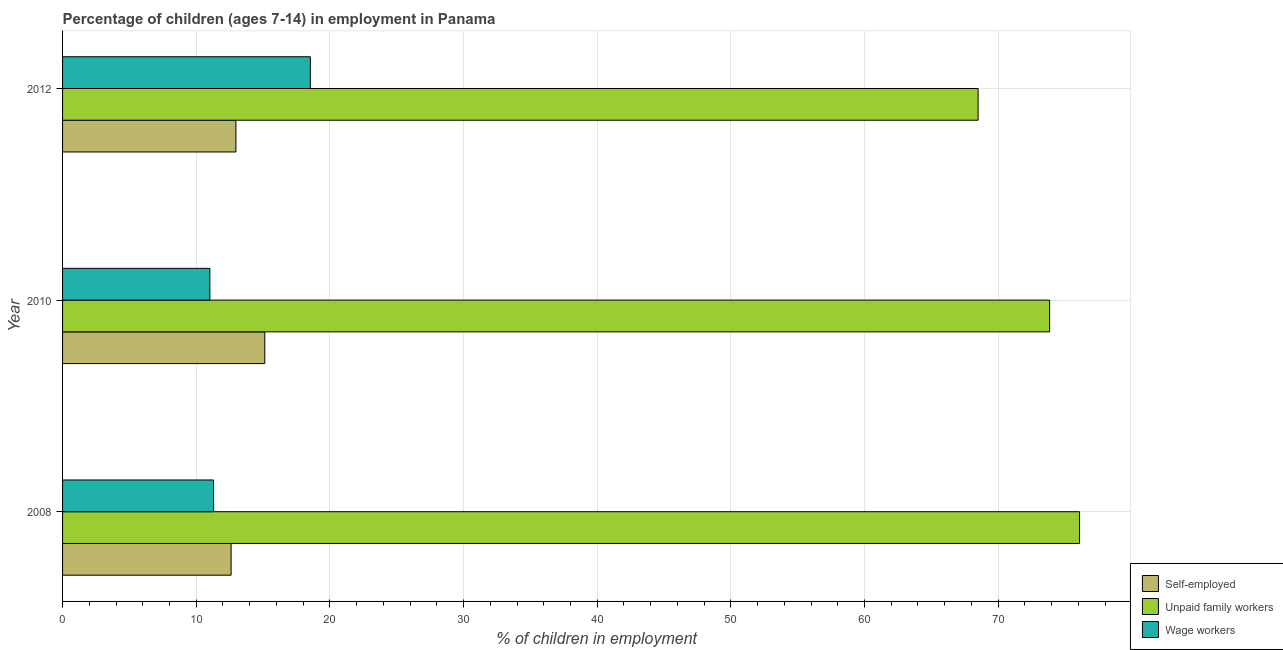Are the number of bars per tick equal to the number of legend labels?
Your response must be concise. Yes. How many bars are there on the 2nd tick from the top?
Your response must be concise. 3. What is the label of the 2nd group of bars from the top?
Give a very brief answer. 2010. In how many cases, is the number of bars for a given year not equal to the number of legend labels?
Keep it short and to the point. 0. What is the percentage of self employed children in 2012?
Keep it short and to the point. 12.97. Across all years, what is the maximum percentage of children employed as unpaid family workers?
Provide a succinct answer. 76.09. Across all years, what is the minimum percentage of self employed children?
Ensure brevity in your answer.  12.61. In which year was the percentage of self employed children maximum?
Your response must be concise. 2010. What is the total percentage of children employed as unpaid family workers in the graph?
Make the answer very short. 218.44. What is the difference between the percentage of self employed children in 2008 and that in 2012?
Give a very brief answer. -0.36. What is the difference between the percentage of children employed as unpaid family workers in 2010 and the percentage of children employed as wage workers in 2008?
Provide a short and direct response. 62.55. What is the average percentage of self employed children per year?
Offer a very short reply. 13.57. In the year 2010, what is the difference between the percentage of self employed children and percentage of children employed as wage workers?
Your answer should be very brief. 4.11. In how many years, is the percentage of children employed as wage workers greater than 64 %?
Ensure brevity in your answer.  0. What is the ratio of the percentage of children employed as wage workers in 2008 to that in 2012?
Your answer should be very brief. 0.61. Is the percentage of children employed as wage workers in 2008 less than that in 2012?
Your answer should be compact. Yes. Is the difference between the percentage of children employed as unpaid family workers in 2010 and 2012 greater than the difference between the percentage of self employed children in 2010 and 2012?
Your answer should be compact. Yes. What is the difference between the highest and the second highest percentage of children employed as unpaid family workers?
Provide a succinct answer. 2.24. What is the difference between the highest and the lowest percentage of children employed as wage workers?
Provide a succinct answer. 7.52. What does the 3rd bar from the top in 2008 represents?
Keep it short and to the point. Self-employed. What does the 3rd bar from the bottom in 2012 represents?
Make the answer very short. Wage workers. Is it the case that in every year, the sum of the percentage of self employed children and percentage of children employed as unpaid family workers is greater than the percentage of children employed as wage workers?
Your response must be concise. Yes. How many bars are there?
Keep it short and to the point. 9. How many years are there in the graph?
Offer a terse response. 3. What is the difference between two consecutive major ticks on the X-axis?
Offer a very short reply. 10. Are the values on the major ticks of X-axis written in scientific E-notation?
Your answer should be very brief. No. Does the graph contain any zero values?
Make the answer very short. No. Does the graph contain grids?
Offer a very short reply. Yes. Where does the legend appear in the graph?
Give a very brief answer. Bottom right. How are the legend labels stacked?
Give a very brief answer. Vertical. What is the title of the graph?
Provide a short and direct response. Percentage of children (ages 7-14) in employment in Panama. Does "Resident buildings and public services" appear as one of the legend labels in the graph?
Your answer should be compact. No. What is the label or title of the X-axis?
Offer a very short reply. % of children in employment. What is the % of children in employment in Self-employed in 2008?
Your answer should be compact. 12.61. What is the % of children in employment in Unpaid family workers in 2008?
Offer a very short reply. 76.09. What is the % of children in employment in Wage workers in 2008?
Make the answer very short. 11.3. What is the % of children in employment of Self-employed in 2010?
Ensure brevity in your answer.  15.13. What is the % of children in employment in Unpaid family workers in 2010?
Make the answer very short. 73.85. What is the % of children in employment of Wage workers in 2010?
Provide a short and direct response. 11.02. What is the % of children in employment in Self-employed in 2012?
Your answer should be very brief. 12.97. What is the % of children in employment in Unpaid family workers in 2012?
Provide a short and direct response. 68.5. What is the % of children in employment in Wage workers in 2012?
Provide a succinct answer. 18.54. Across all years, what is the maximum % of children in employment of Self-employed?
Your answer should be compact. 15.13. Across all years, what is the maximum % of children in employment of Unpaid family workers?
Your answer should be very brief. 76.09. Across all years, what is the maximum % of children in employment of Wage workers?
Give a very brief answer. 18.54. Across all years, what is the minimum % of children in employment of Self-employed?
Offer a very short reply. 12.61. Across all years, what is the minimum % of children in employment in Unpaid family workers?
Your answer should be compact. 68.5. Across all years, what is the minimum % of children in employment in Wage workers?
Offer a very short reply. 11.02. What is the total % of children in employment of Self-employed in the graph?
Provide a short and direct response. 40.71. What is the total % of children in employment of Unpaid family workers in the graph?
Keep it short and to the point. 218.44. What is the total % of children in employment in Wage workers in the graph?
Ensure brevity in your answer.  40.86. What is the difference between the % of children in employment in Self-employed in 2008 and that in 2010?
Ensure brevity in your answer.  -2.52. What is the difference between the % of children in employment of Unpaid family workers in 2008 and that in 2010?
Keep it short and to the point. 2.24. What is the difference between the % of children in employment in Wage workers in 2008 and that in 2010?
Offer a very short reply. 0.28. What is the difference between the % of children in employment of Self-employed in 2008 and that in 2012?
Provide a short and direct response. -0.36. What is the difference between the % of children in employment in Unpaid family workers in 2008 and that in 2012?
Your answer should be compact. 7.59. What is the difference between the % of children in employment of Wage workers in 2008 and that in 2012?
Provide a succinct answer. -7.24. What is the difference between the % of children in employment in Self-employed in 2010 and that in 2012?
Make the answer very short. 2.16. What is the difference between the % of children in employment of Unpaid family workers in 2010 and that in 2012?
Keep it short and to the point. 5.35. What is the difference between the % of children in employment of Wage workers in 2010 and that in 2012?
Give a very brief answer. -7.52. What is the difference between the % of children in employment in Self-employed in 2008 and the % of children in employment in Unpaid family workers in 2010?
Your response must be concise. -61.24. What is the difference between the % of children in employment in Self-employed in 2008 and the % of children in employment in Wage workers in 2010?
Ensure brevity in your answer.  1.59. What is the difference between the % of children in employment of Unpaid family workers in 2008 and the % of children in employment of Wage workers in 2010?
Your answer should be very brief. 65.07. What is the difference between the % of children in employment of Self-employed in 2008 and the % of children in employment of Unpaid family workers in 2012?
Offer a very short reply. -55.89. What is the difference between the % of children in employment of Self-employed in 2008 and the % of children in employment of Wage workers in 2012?
Offer a very short reply. -5.93. What is the difference between the % of children in employment in Unpaid family workers in 2008 and the % of children in employment in Wage workers in 2012?
Give a very brief answer. 57.55. What is the difference between the % of children in employment in Self-employed in 2010 and the % of children in employment in Unpaid family workers in 2012?
Offer a terse response. -53.37. What is the difference between the % of children in employment in Self-employed in 2010 and the % of children in employment in Wage workers in 2012?
Offer a very short reply. -3.41. What is the difference between the % of children in employment of Unpaid family workers in 2010 and the % of children in employment of Wage workers in 2012?
Provide a succinct answer. 55.31. What is the average % of children in employment in Self-employed per year?
Your answer should be compact. 13.57. What is the average % of children in employment in Unpaid family workers per year?
Make the answer very short. 72.81. What is the average % of children in employment in Wage workers per year?
Your answer should be compact. 13.62. In the year 2008, what is the difference between the % of children in employment of Self-employed and % of children in employment of Unpaid family workers?
Your answer should be compact. -63.48. In the year 2008, what is the difference between the % of children in employment of Self-employed and % of children in employment of Wage workers?
Your answer should be very brief. 1.31. In the year 2008, what is the difference between the % of children in employment in Unpaid family workers and % of children in employment in Wage workers?
Your response must be concise. 64.79. In the year 2010, what is the difference between the % of children in employment in Self-employed and % of children in employment in Unpaid family workers?
Offer a very short reply. -58.72. In the year 2010, what is the difference between the % of children in employment of Self-employed and % of children in employment of Wage workers?
Ensure brevity in your answer.  4.11. In the year 2010, what is the difference between the % of children in employment in Unpaid family workers and % of children in employment in Wage workers?
Ensure brevity in your answer.  62.83. In the year 2012, what is the difference between the % of children in employment in Self-employed and % of children in employment in Unpaid family workers?
Offer a terse response. -55.53. In the year 2012, what is the difference between the % of children in employment in Self-employed and % of children in employment in Wage workers?
Offer a very short reply. -5.57. In the year 2012, what is the difference between the % of children in employment in Unpaid family workers and % of children in employment in Wage workers?
Provide a succinct answer. 49.96. What is the ratio of the % of children in employment of Self-employed in 2008 to that in 2010?
Your answer should be very brief. 0.83. What is the ratio of the % of children in employment in Unpaid family workers in 2008 to that in 2010?
Offer a very short reply. 1.03. What is the ratio of the % of children in employment in Wage workers in 2008 to that in 2010?
Your answer should be compact. 1.03. What is the ratio of the % of children in employment in Self-employed in 2008 to that in 2012?
Provide a short and direct response. 0.97. What is the ratio of the % of children in employment of Unpaid family workers in 2008 to that in 2012?
Your answer should be very brief. 1.11. What is the ratio of the % of children in employment of Wage workers in 2008 to that in 2012?
Your answer should be very brief. 0.61. What is the ratio of the % of children in employment of Self-employed in 2010 to that in 2012?
Your answer should be very brief. 1.17. What is the ratio of the % of children in employment in Unpaid family workers in 2010 to that in 2012?
Provide a short and direct response. 1.08. What is the ratio of the % of children in employment of Wage workers in 2010 to that in 2012?
Make the answer very short. 0.59. What is the difference between the highest and the second highest % of children in employment of Self-employed?
Provide a short and direct response. 2.16. What is the difference between the highest and the second highest % of children in employment in Unpaid family workers?
Provide a succinct answer. 2.24. What is the difference between the highest and the second highest % of children in employment in Wage workers?
Your answer should be compact. 7.24. What is the difference between the highest and the lowest % of children in employment of Self-employed?
Offer a very short reply. 2.52. What is the difference between the highest and the lowest % of children in employment in Unpaid family workers?
Keep it short and to the point. 7.59. What is the difference between the highest and the lowest % of children in employment in Wage workers?
Offer a terse response. 7.52. 